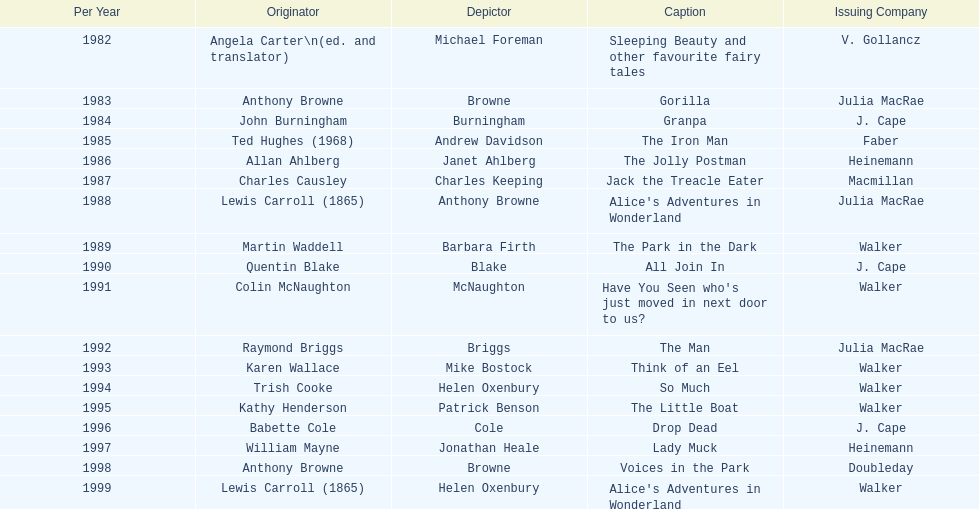How many titles did walker publish? 6. Give me the full table as a dictionary. {'header': ['Per Year', 'Originator', 'Depictor', 'Caption', 'Issuing Company'], 'rows': [['1982', 'Angela Carter\\n(ed. and translator)', 'Michael Foreman', 'Sleeping Beauty and other favourite fairy tales', 'V. Gollancz'], ['1983', 'Anthony Browne', 'Browne', 'Gorilla', 'Julia MacRae'], ['1984', 'John Burningham', 'Burningham', 'Granpa', 'J. Cape'], ['1985', 'Ted Hughes (1968)', 'Andrew Davidson', 'The Iron Man', 'Faber'], ['1986', 'Allan Ahlberg', 'Janet Ahlberg', 'The Jolly Postman', 'Heinemann'], ['1987', 'Charles Causley', 'Charles Keeping', 'Jack the Treacle Eater', 'Macmillan'], ['1988', 'Lewis Carroll (1865)', 'Anthony Browne', "Alice's Adventures in Wonderland", 'Julia MacRae'], ['1989', 'Martin Waddell', 'Barbara Firth', 'The Park in the Dark', 'Walker'], ['1990', 'Quentin Blake', 'Blake', 'All Join In', 'J. Cape'], ['1991', 'Colin McNaughton', 'McNaughton', "Have You Seen who's just moved in next door to us?", 'Walker'], ['1992', 'Raymond Briggs', 'Briggs', 'The Man', 'Julia MacRae'], ['1993', 'Karen Wallace', 'Mike Bostock', 'Think of an Eel', 'Walker'], ['1994', 'Trish Cooke', 'Helen Oxenbury', 'So Much', 'Walker'], ['1995', 'Kathy Henderson', 'Patrick Benson', 'The Little Boat', 'Walker'], ['1996', 'Babette Cole', 'Cole', 'Drop Dead', 'J. Cape'], ['1997', 'William Mayne', 'Jonathan Heale', 'Lady Muck', 'Heinemann'], ['1998', 'Anthony Browne', 'Browne', 'Voices in the Park', 'Doubleday'], ['1999', 'Lewis Carroll (1865)', 'Helen Oxenbury', "Alice's Adventures in Wonderland", 'Walker']]} 